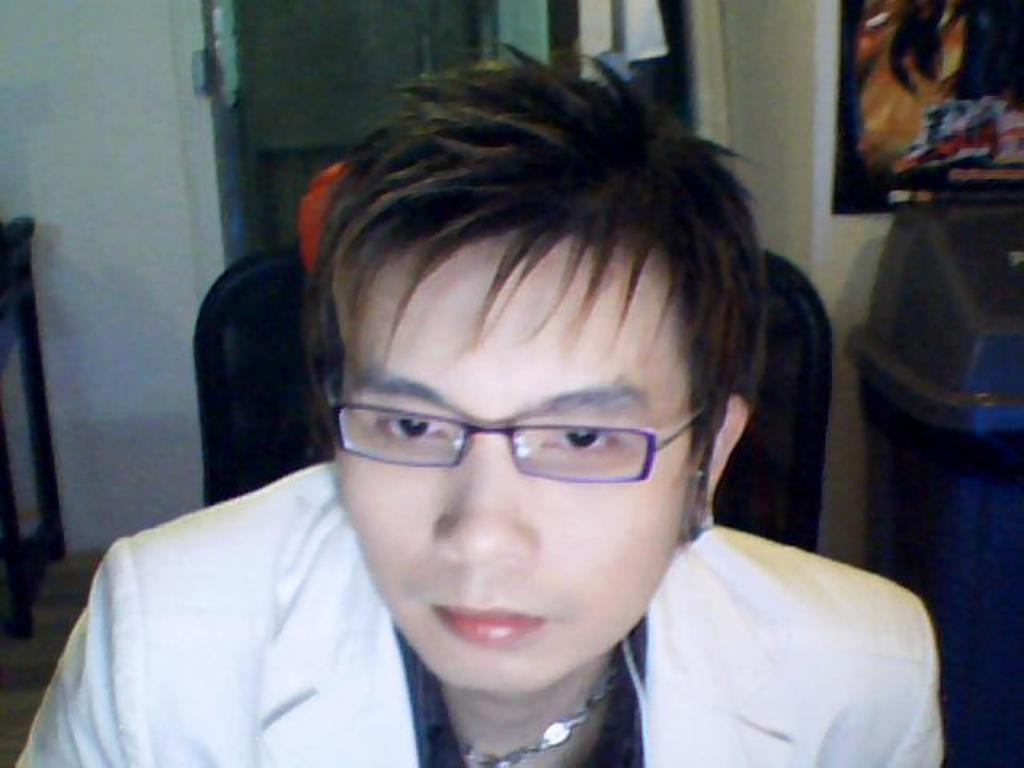What is the person in the image doing? The person is sitting on a chair in the image. Can you describe the person's appearance? The person is wearing spectacles. What can be seen in the background of the image? There is a wall, a poster, and a dustbin in the background of the image. What type of stove is visible in the image? There is no stove present in the image. Can you tell me what the representative is saying in the image? There is no representative or dialogue present in the image. 